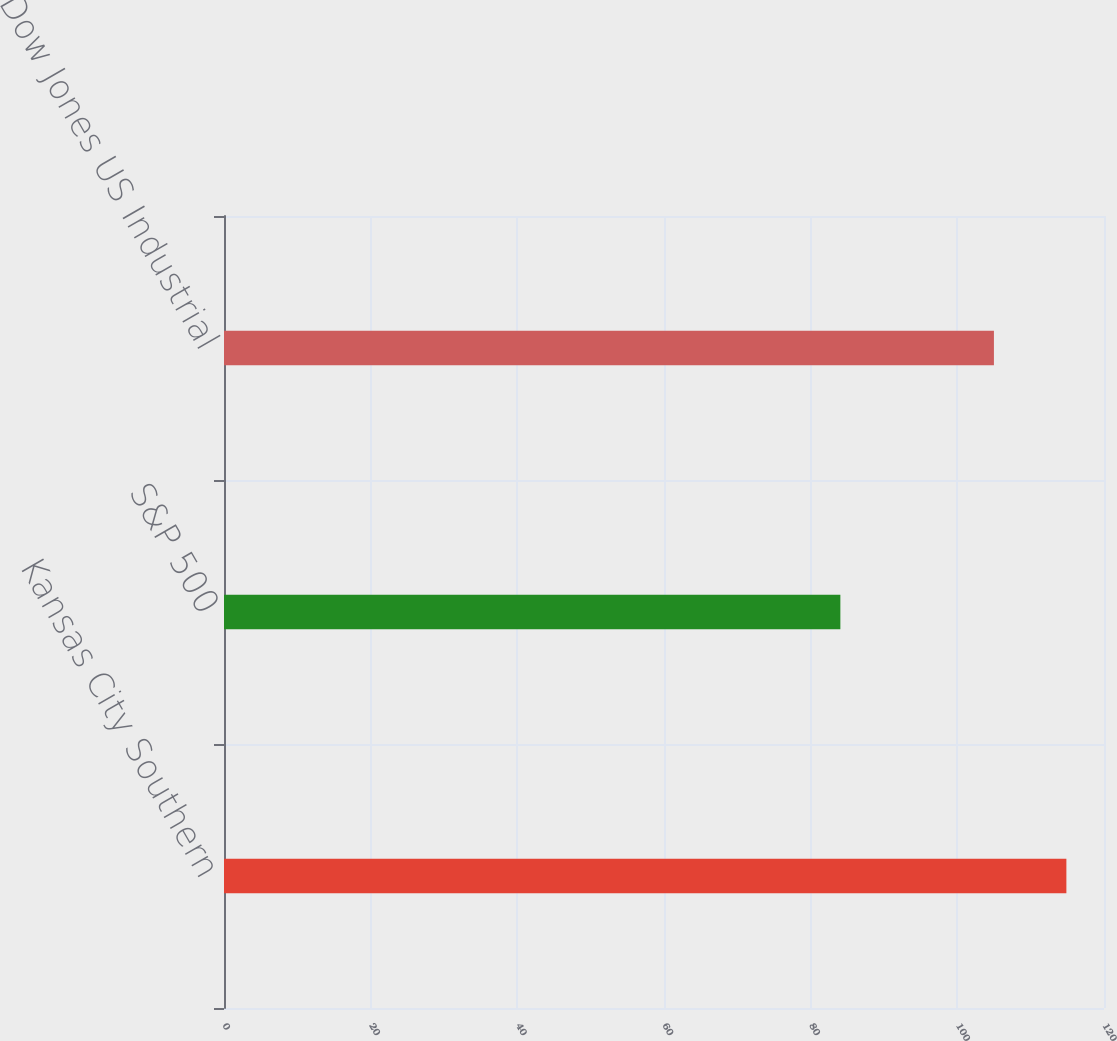<chart> <loc_0><loc_0><loc_500><loc_500><bar_chart><fcel>Kansas City Southern<fcel>S&P 500<fcel>Dow Jones US Industrial<nl><fcel>114.87<fcel>84.05<fcel>104.99<nl></chart> 